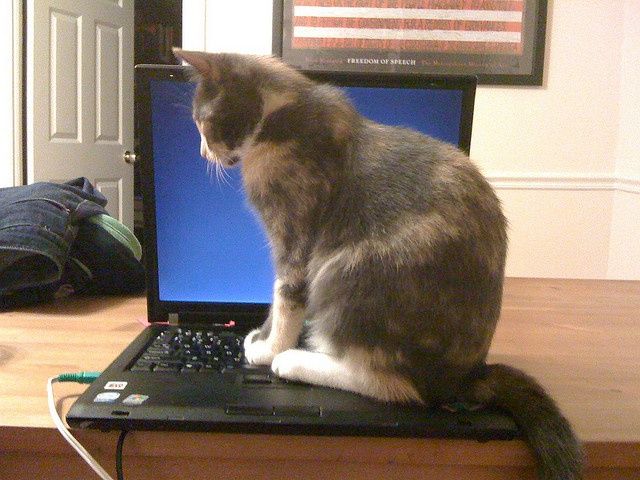Describe the objects in this image and their specific colors. I can see a dining table in white, black, maroon, and gray tones in this image. 